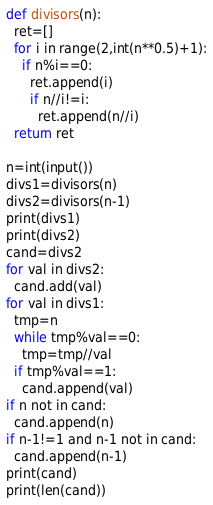<code> <loc_0><loc_0><loc_500><loc_500><_Python_>def divisors(n):
  ret=[]
  for i in range(2,int(n**0.5)+1):
    if n%i==0:
      ret.append(i)
      if n//i!=i:
        ret.append(n//i)
  return ret

n=int(input())
divs1=divisors(n)
divs2=divisors(n-1)
print(divs1)
print(divs2)
cand=divs2
for val in divs2:
  cand.add(val)
for val in divs1:
  tmp=n
  while tmp%val==0:
    tmp=tmp//val
  if tmp%val==1:
    cand.append(val)
if n not in cand:
  cand.append(n)
if n-1!=1 and n-1 not in cand:
  cand.append(n-1)
print(cand)
print(len(cand))</code> 